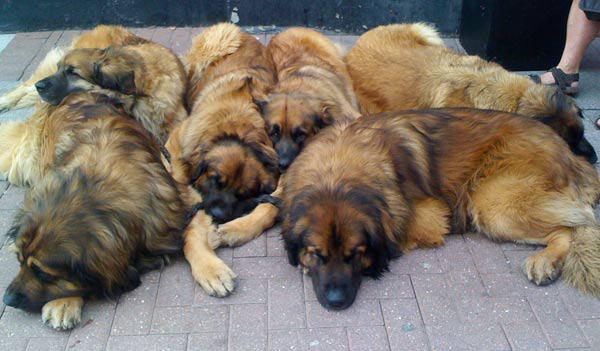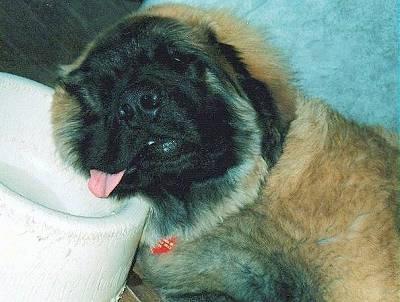The first image is the image on the left, the second image is the image on the right. Given the left and right images, does the statement "A dog's pink tongue is visible in one image." hold true? Answer yes or no. Yes. 